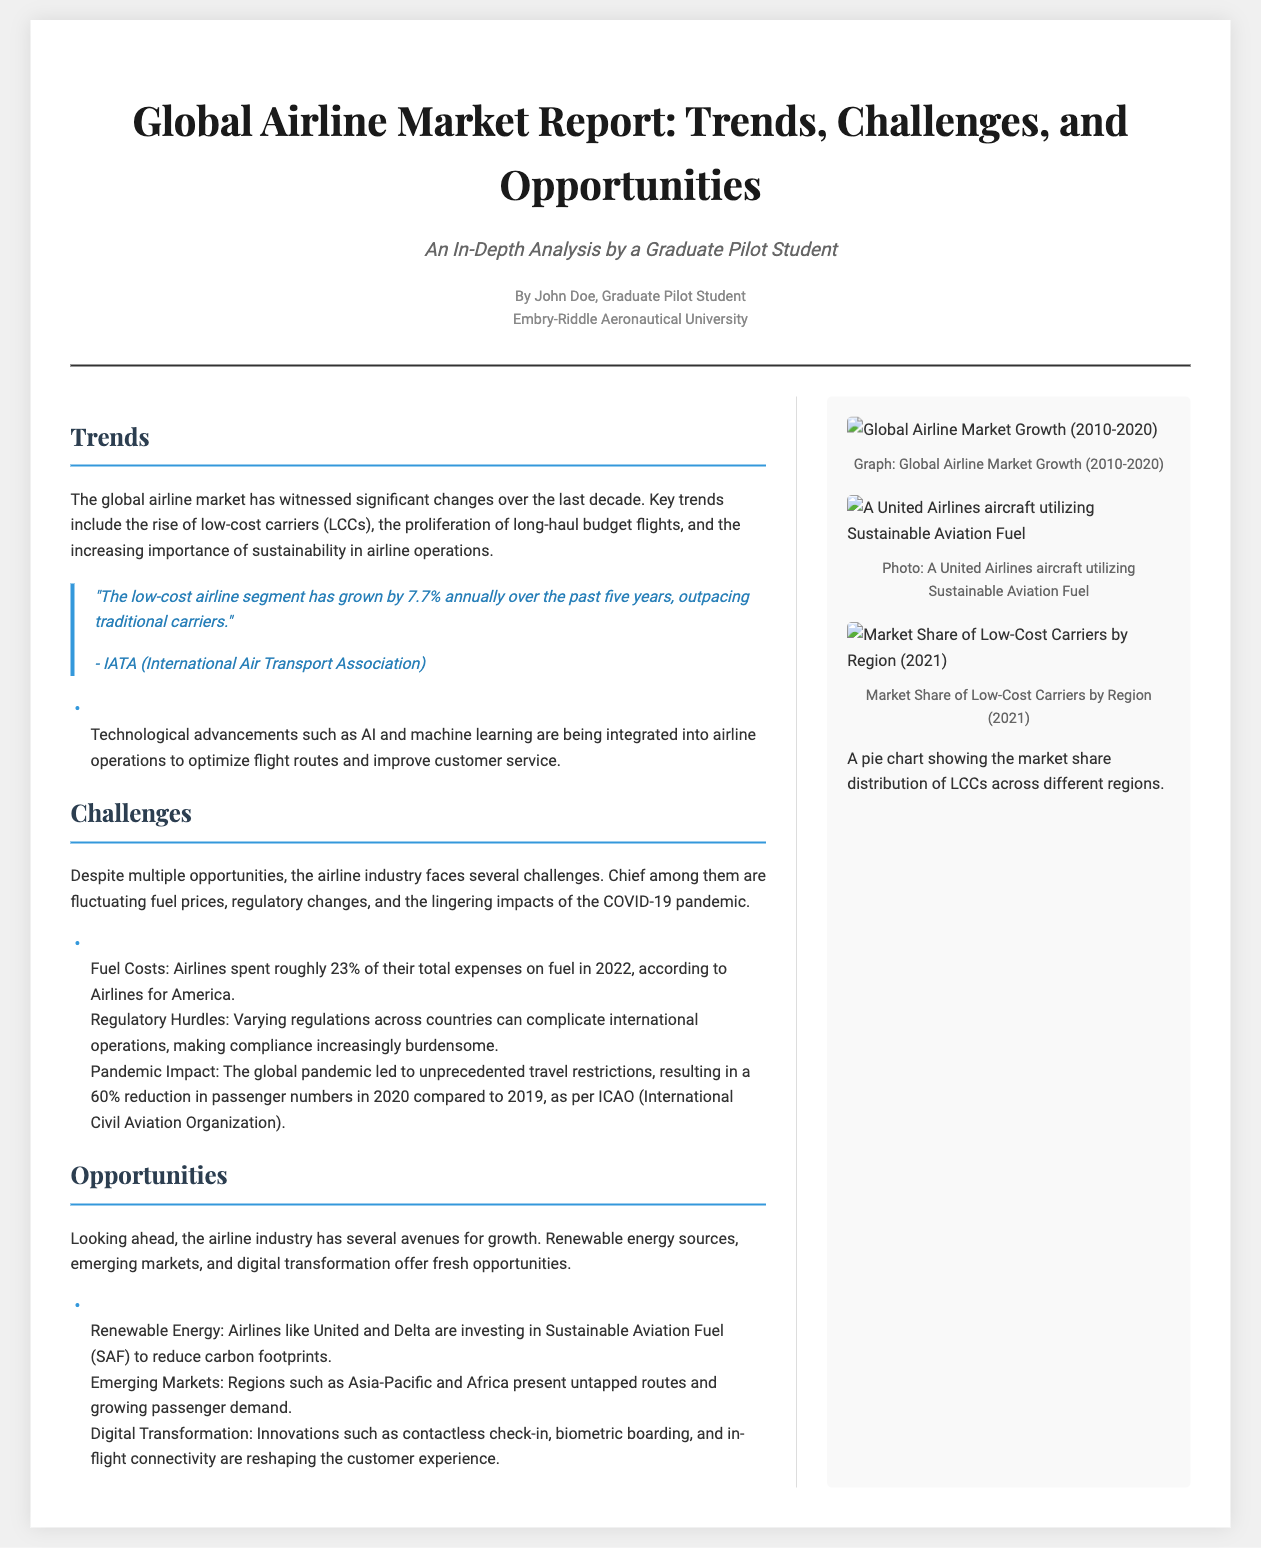What is the title of the report? The title of the report is stated in the header of the document.
Answer: Global Airline Market Report: Trends, Challenges, and Opportunities Who authored the report? The author's name is mentioned right below the title in the header section.
Answer: John Doe What is the annual growth rate of low-cost airlines? This information is found in the Trends section of the document.
Answer: 7.7% What percentage of total expenses do airlines spend on fuel in 2022? The specific expense percentage is detailed in the Challenges section.
Answer: 23% What are the two major challenges faced by the airline industry? Challenges are listed in the Challenges section.
Answer: Fuel prices, regulatory changes Which airline is mentioned as investing in Sustainable Aviation Fuel? This information is provided in the Opportunities section of the document.
Answer: United What two regions are identified as having emerging market opportunities? The emerging markets are detailed in the Opportunities section.
Answer: Asia-Pacific, Africa What visual aids are included in the sidebar? The sidebar contains images as indicated by the different sections in the sidebar content.
Answer: Graphs and photographs What impact did the COVID-19 pandemic have on passenger numbers in 2020? The specific impact is described in the Challenges section.
Answer: 60% reduction 